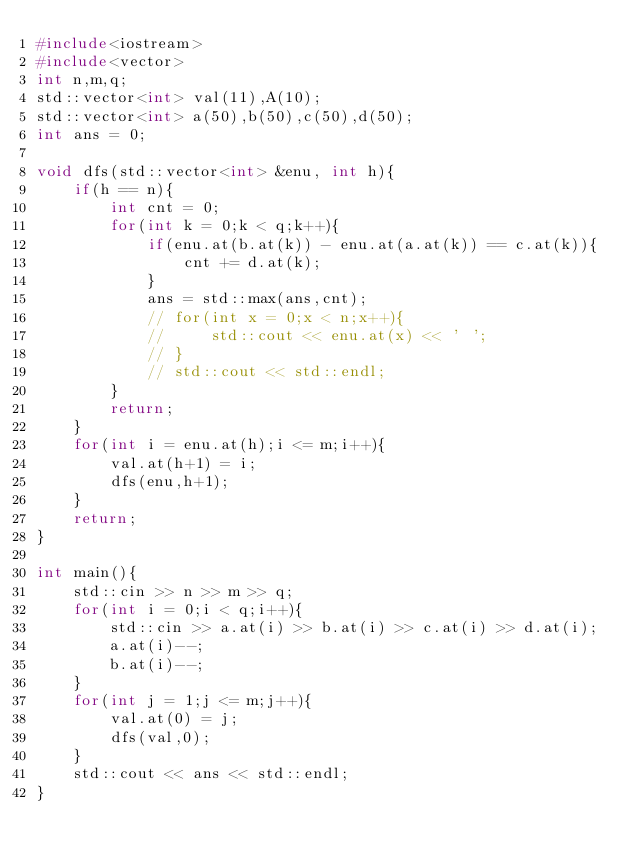<code> <loc_0><loc_0><loc_500><loc_500><_C++_>#include<iostream>
#include<vector>
int n,m,q;
std::vector<int> val(11),A(10);
std::vector<int> a(50),b(50),c(50),d(50);
int ans = 0;

void dfs(std::vector<int> &enu, int h){
    if(h == n){
        int cnt = 0;
        for(int k = 0;k < q;k++){
            if(enu.at(b.at(k)) - enu.at(a.at(k)) == c.at(k)){
                cnt += d.at(k);
            }
            ans = std::max(ans,cnt);
            // for(int x = 0;x < n;x++){
            //     std::cout << enu.at(x) << ' ';
            // }
            // std::cout << std::endl;
        }
        return;
    }
    for(int i = enu.at(h);i <= m;i++){
        val.at(h+1) = i;
        dfs(enu,h+1);
    }
    return;
}

int main(){
    std::cin >> n >> m >> q;
    for(int i = 0;i < q;i++){
        std::cin >> a.at(i) >> b.at(i) >> c.at(i) >> d.at(i);
        a.at(i)--;
        b.at(i)--;
    }
    for(int j = 1;j <= m;j++){
        val.at(0) = j;
        dfs(val,0);
    }
    std::cout << ans << std::endl;
}</code> 